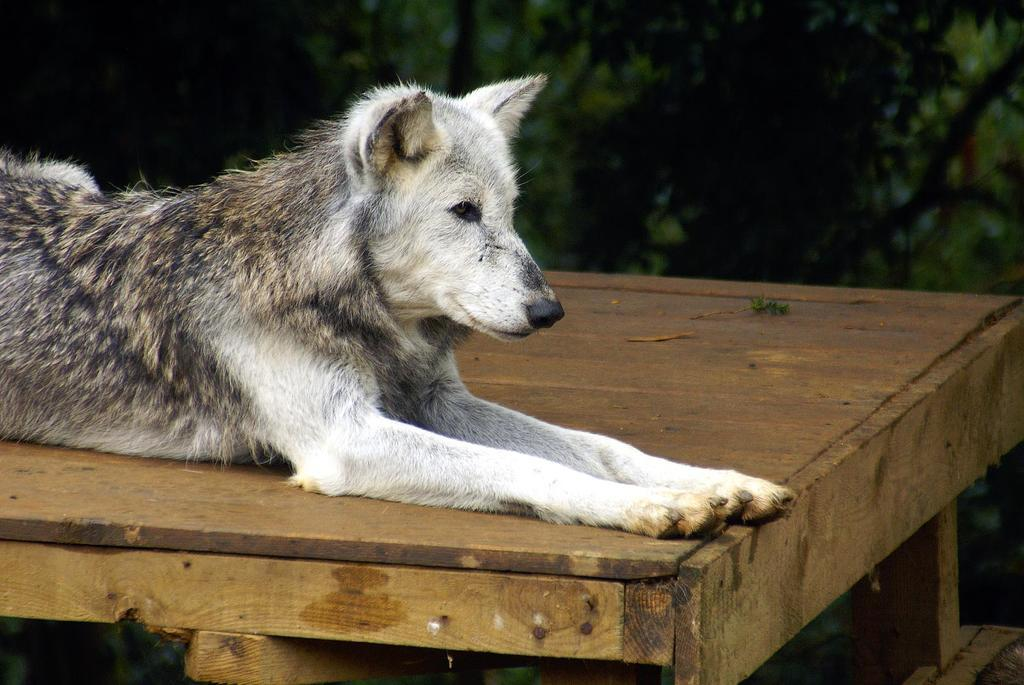What animal is present in the image? There is a dog in the image. Where is the dog located? The dog is sitting on a wooden table. Can you describe the background of the image? The background of the image is blurred. What type of fang does the dog have in the image? There is no mention of a fang in the image, as dogs do not have fangs like some other animals. 